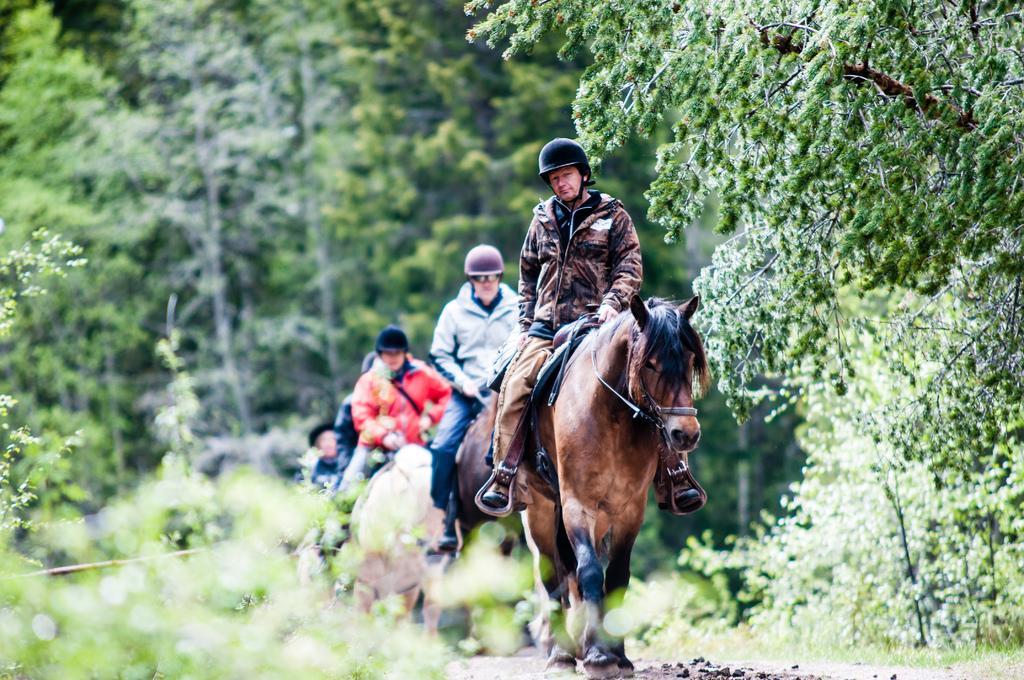Can you describe this image briefly? In this picture there is a person riding a horse wearing a black helmet. In the background there trees and plant. 